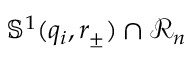Convert formula to latex. <formula><loc_0><loc_0><loc_500><loc_500>\mathbb { S } ^ { 1 } ( q _ { i } , r _ { \pm } ) \cap \ m a t h s c r { R } _ { n }</formula> 